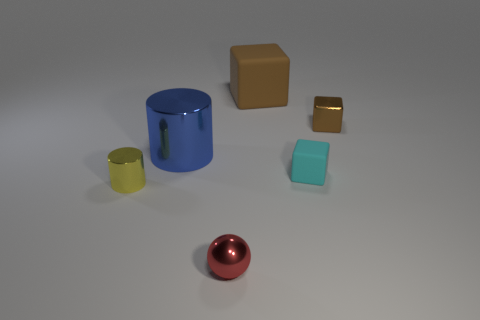How many objects can be seen on the surface, and can you describe their colors and shapes? There are five objects visible on the surface. From left to right: a small yellow cylinder, a large blue cylinder with a handle, a brown cube, a small golden cube, and a turquoise rectangular prism. In the foreground, there's also a shiny red sphere. Which object appears to be the most reflective? The shiny red sphere in the foreground appears to be the most reflective, displaying clear highlights and a smooth surface that suggests a mirrored finish. 